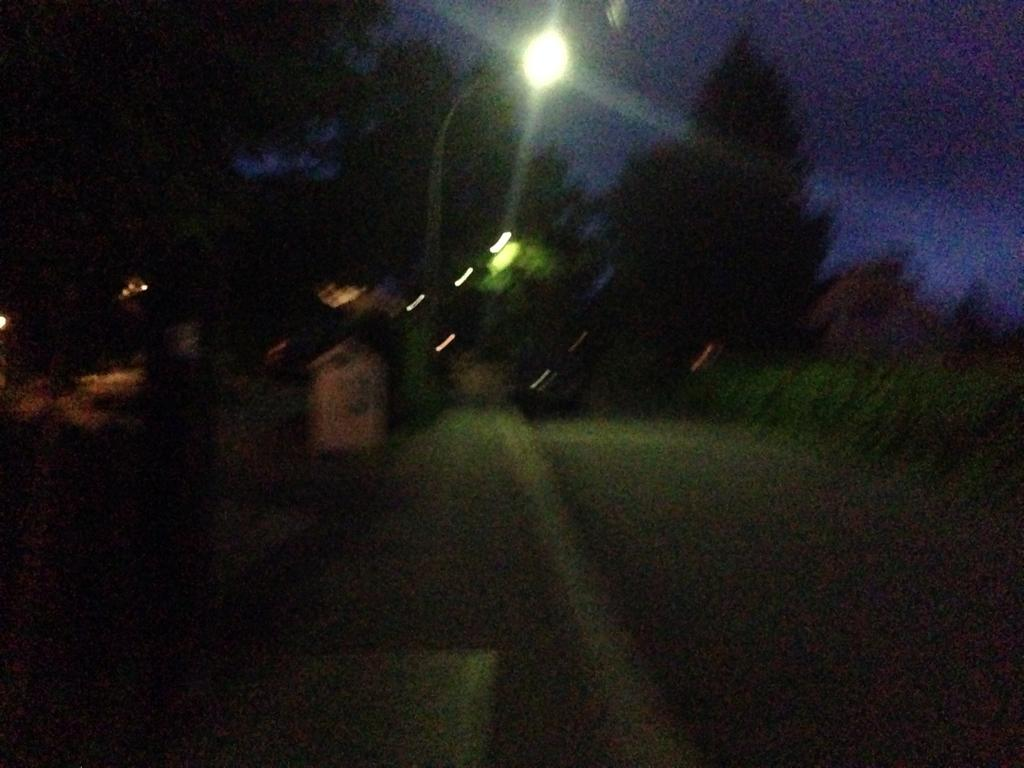What is the main object in the image? There is a street light in the image. What can be seen in the background of the image? There are trees in the background of the image. What type of cheese is hanging from the branches of the trees in the image? There is no cheese present in the image; it only features a street light and trees in the background. 